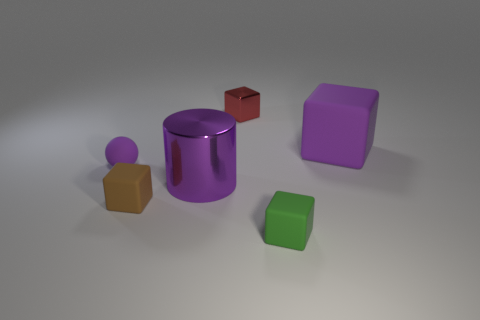What is the shape of the large shiny object that is the same color as the sphere?
Provide a short and direct response. Cylinder. There is a object that is both to the right of the tiny red metal object and behind the matte ball; what is its shape?
Give a very brief answer. Cube. Do the metal thing that is on the right side of the big shiny object and the large cylinder have the same color?
Ensure brevity in your answer.  No. Do the small object in front of the brown object and the purple rubber thing in front of the purple block have the same shape?
Offer a terse response. No. What is the size of the purple thing that is to the right of the red metal thing?
Make the answer very short. Large. What is the size of the purple rubber object behind the object that is to the left of the tiny brown matte block?
Provide a succinct answer. Large. Are there more tiny brown cubes than metal objects?
Your answer should be very brief. No. Is the number of balls that are behind the small red metallic block greater than the number of matte blocks that are on the left side of the big cube?
Give a very brief answer. No. There is a object that is both behind the brown matte block and in front of the purple rubber ball; what size is it?
Make the answer very short. Large. What number of other purple cylinders have the same size as the cylinder?
Ensure brevity in your answer.  0. 